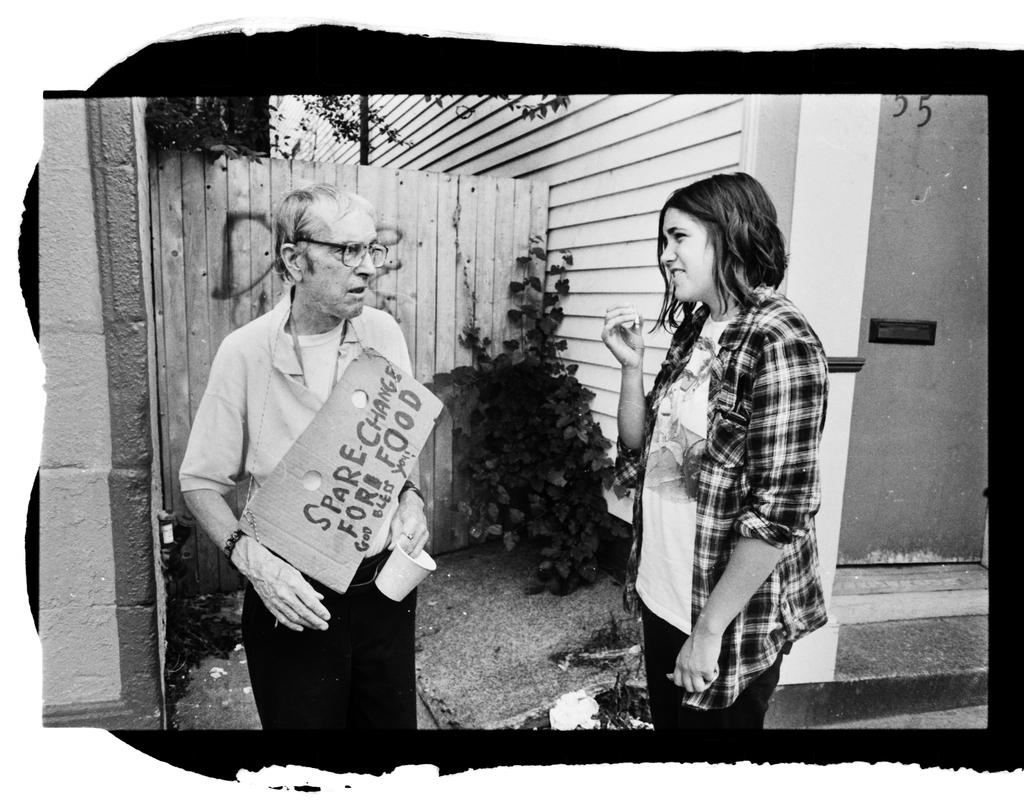What type of structure is visible in the image? There is a wall in the image. Is there any entrance visible in the image? Yes, there is a door in the image. What type of vegetation is present in the image? There is a plant in the image. How many people are in the image? There are two people standing in the image. What type of carriage is being used by the people in the image? There is no carriage present in the image; it only shows a wall, a door, a plant, and two people standing. How does the match between the two people in the image compare to the plant? There is no match or comparison being made in the image, as it only shows a wall, a door, a plant, and two people standing. 